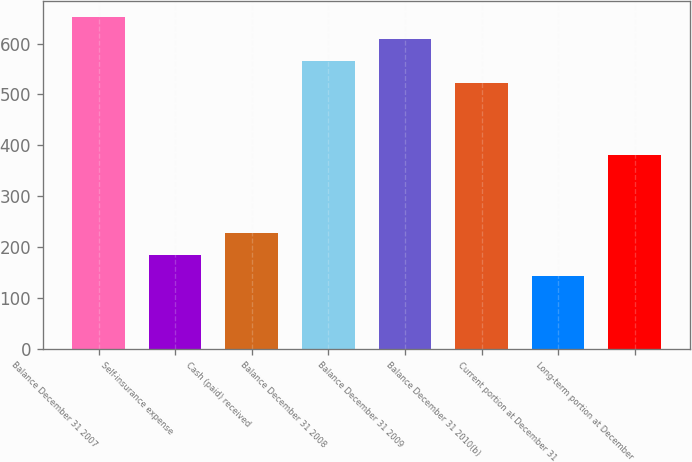Convert chart. <chart><loc_0><loc_0><loc_500><loc_500><bar_chart><fcel>Balance December 31 2007<fcel>Self-insurance expense<fcel>Cash (paid) received<fcel>Balance December 31 2008<fcel>Balance December 31 2009<fcel>Balance December 31 2010(b)<fcel>Current portion at December 31<fcel>Long-term portion at December<nl><fcel>651.7<fcel>184.9<fcel>227.8<fcel>565.9<fcel>608.8<fcel>523<fcel>142<fcel>381<nl></chart> 